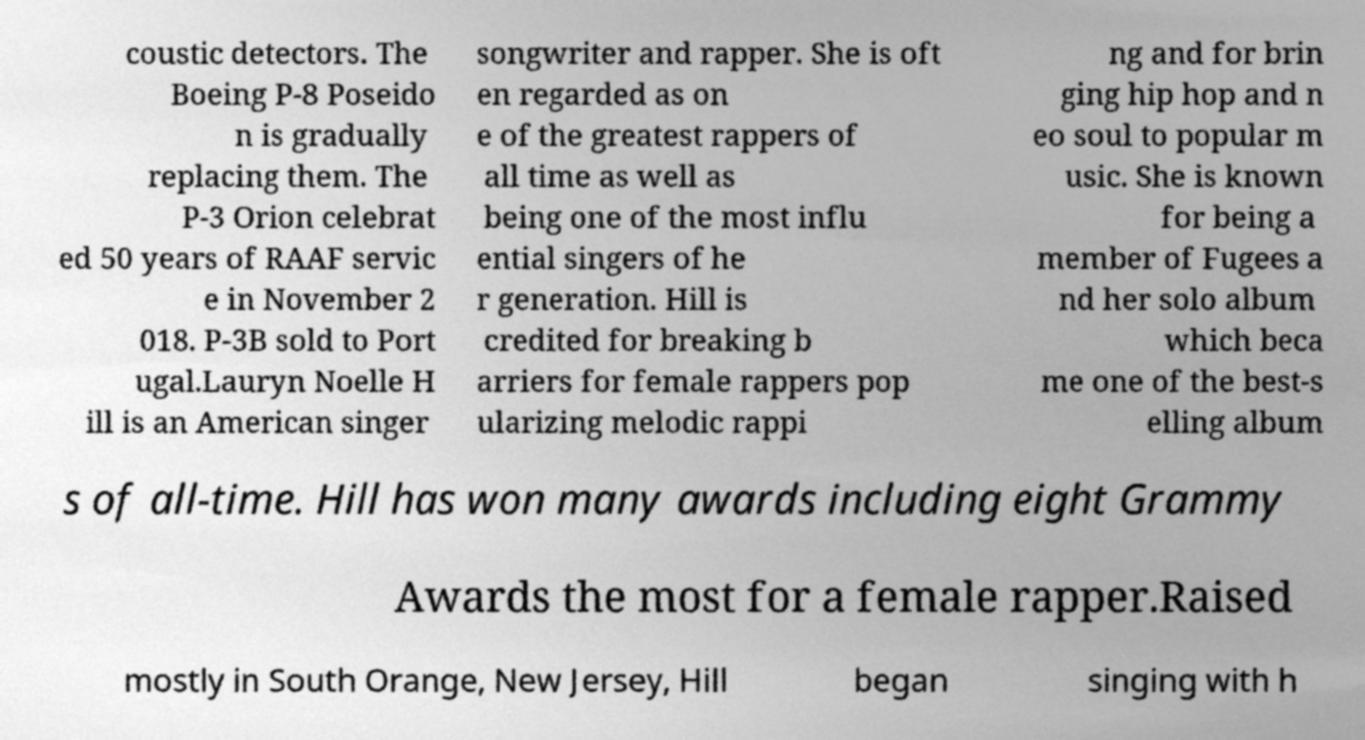Please read and relay the text visible in this image. What does it say? coustic detectors. The Boeing P-8 Poseido n is gradually replacing them. The P-3 Orion celebrat ed 50 years of RAAF servic e in November 2 018. P-3B sold to Port ugal.Lauryn Noelle H ill is an American singer songwriter and rapper. She is oft en regarded as on e of the greatest rappers of all time as well as being one of the most influ ential singers of he r generation. Hill is credited for breaking b arriers for female rappers pop ularizing melodic rappi ng and for brin ging hip hop and n eo soul to popular m usic. She is known for being a member of Fugees a nd her solo album which beca me one of the best-s elling album s of all-time. Hill has won many awards including eight Grammy Awards the most for a female rapper.Raised mostly in South Orange, New Jersey, Hill began singing with h 